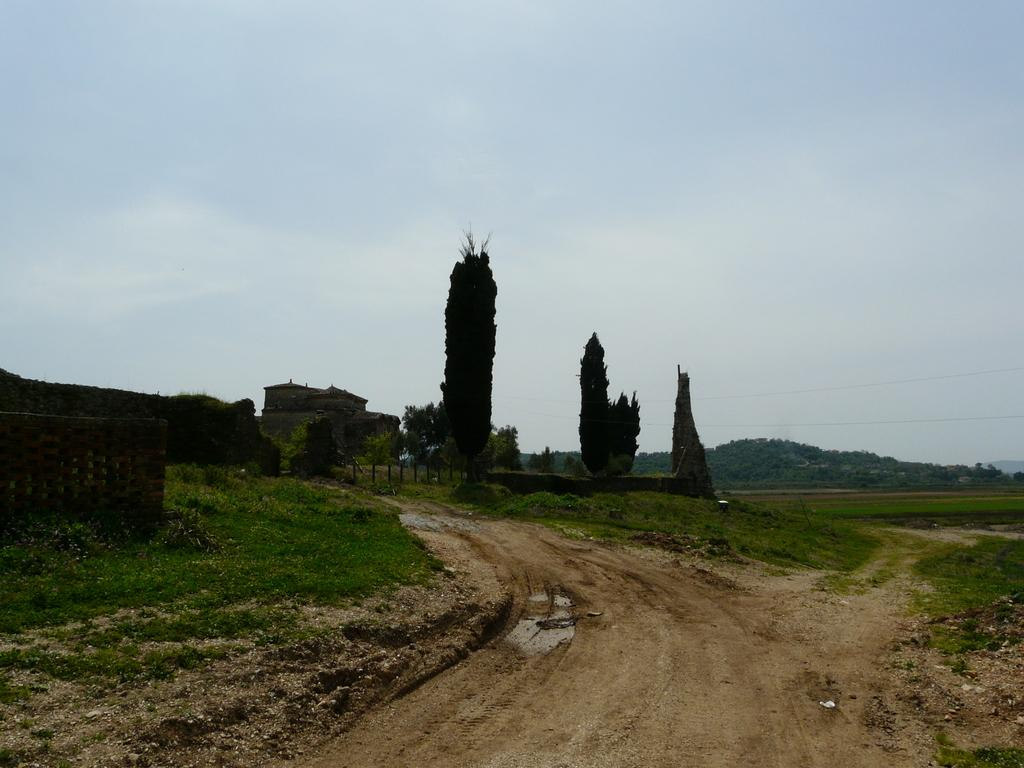What type of road is visible in the image? There is a sand road in the image. What can be seen growing around the sand road? There is a lot of grass around the sand road. What type of structure is present in the image? There is a house in the image. What geographical feature can be seen in the background of the image? There is a mountain visible in the background of the image. What type of pest is crawling on the house in the image? There is no pest visible on the house in the image. Who is the friend that can be seen standing next to the house in the image? There is no person, friend or otherwise, visible in the image. 